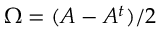<formula> <loc_0><loc_0><loc_500><loc_500>\Omega = ( A - A ^ { t } ) / 2</formula> 